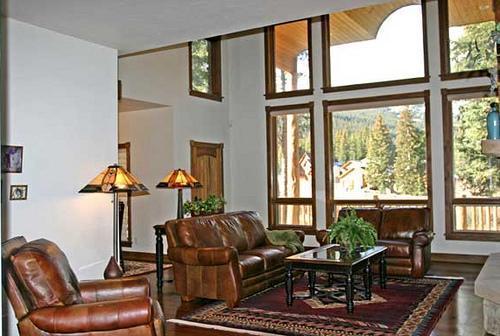How many couches are visible?
Give a very brief answer. 2. 